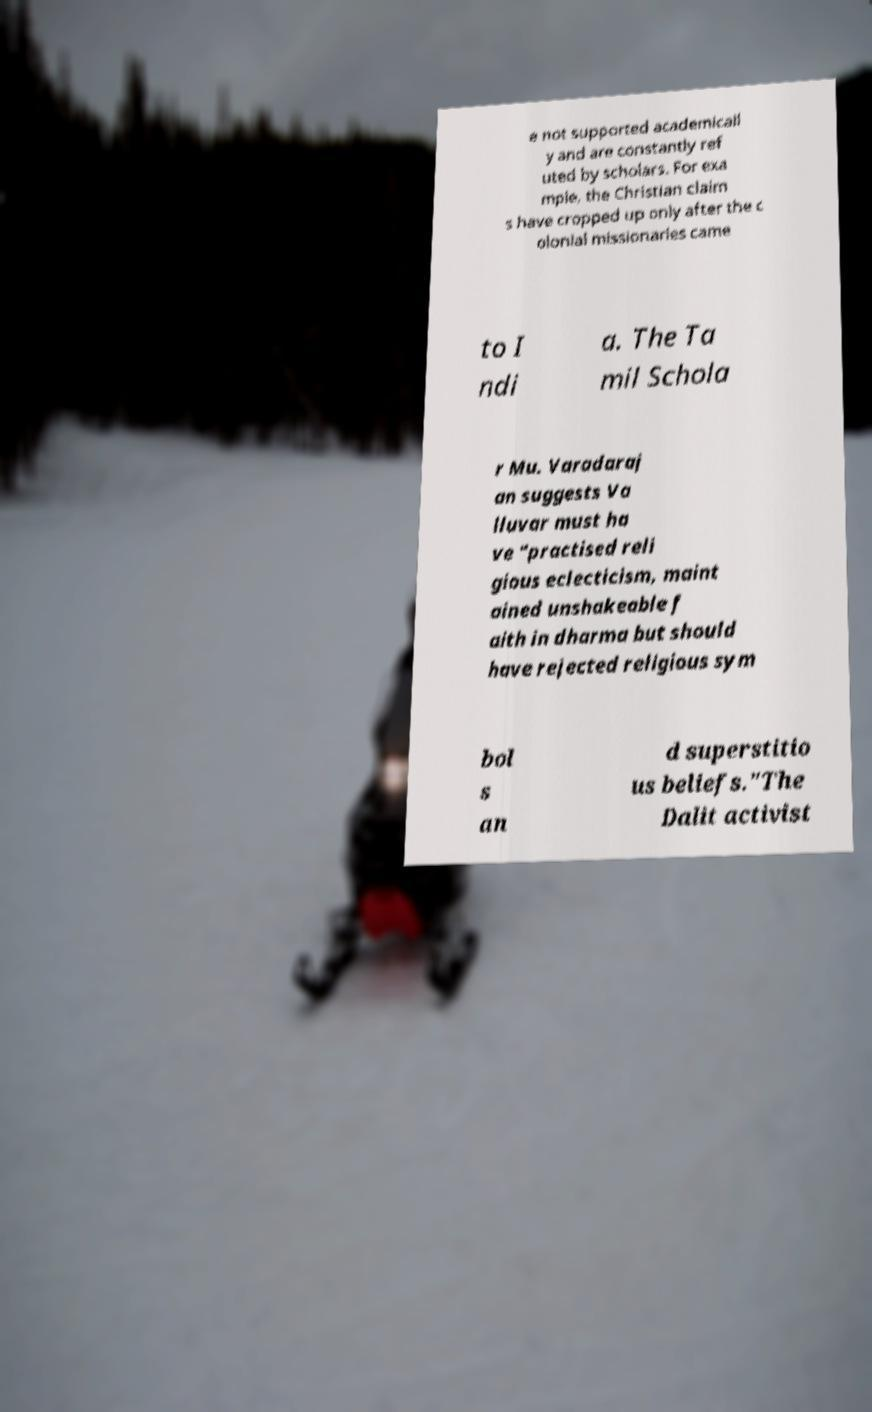Can you accurately transcribe the text from the provided image for me? e not supported academicall y and are constantly ref uted by scholars. For exa mple, the Christian claim s have cropped up only after the c olonial missionaries came to I ndi a. The Ta mil Schola r Mu. Varadaraj an suggests Va lluvar must ha ve "practised reli gious eclecticism, maint ained unshakeable f aith in dharma but should have rejected religious sym bol s an d superstitio us beliefs."The Dalit activist 